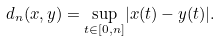<formula> <loc_0><loc_0><loc_500><loc_500>d _ { n } ( x , y ) = \underset { t \in [ 0 , n ] } \sup { | x ( t ) - y ( t ) | } .</formula> 